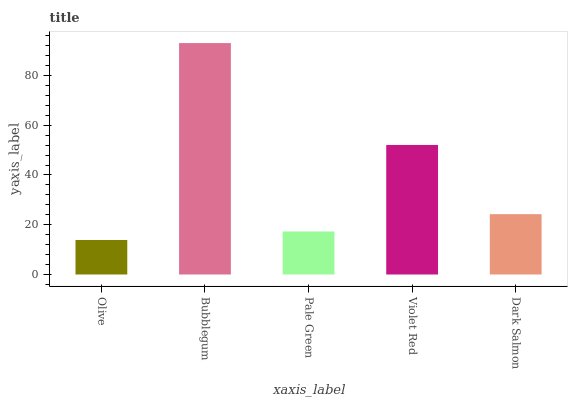Is Olive the minimum?
Answer yes or no. Yes. Is Bubblegum the maximum?
Answer yes or no. Yes. Is Pale Green the minimum?
Answer yes or no. No. Is Pale Green the maximum?
Answer yes or no. No. Is Bubblegum greater than Pale Green?
Answer yes or no. Yes. Is Pale Green less than Bubblegum?
Answer yes or no. Yes. Is Pale Green greater than Bubblegum?
Answer yes or no. No. Is Bubblegum less than Pale Green?
Answer yes or no. No. Is Dark Salmon the high median?
Answer yes or no. Yes. Is Dark Salmon the low median?
Answer yes or no. Yes. Is Olive the high median?
Answer yes or no. No. Is Olive the low median?
Answer yes or no. No. 